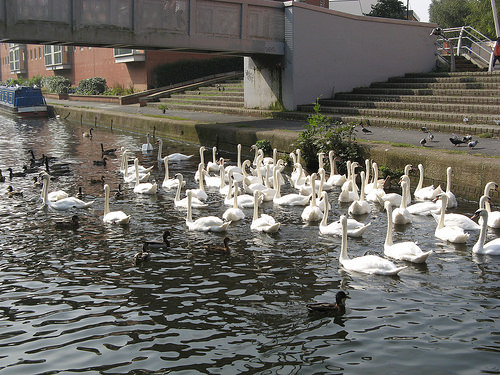<image>
Is there a water on the bird? Yes. Looking at the image, I can see the water is positioned on top of the bird, with the bird providing support. 